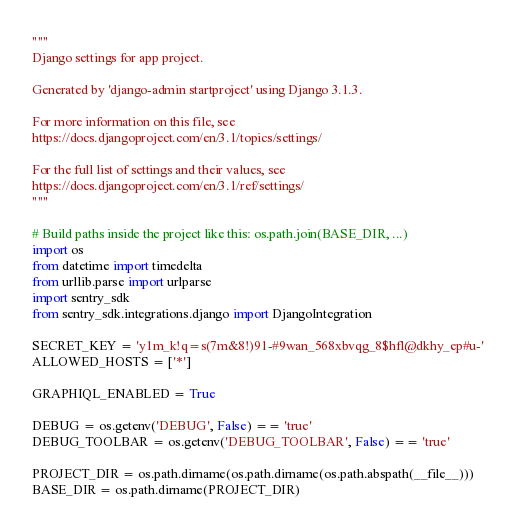Convert code to text. <code><loc_0><loc_0><loc_500><loc_500><_Python_>"""
Django settings for app project.

Generated by 'django-admin startproject' using Django 3.1.3.

For more information on this file, see
https://docs.djangoproject.com/en/3.1/topics/settings/

For the full list of settings and their values, see
https://docs.djangoproject.com/en/3.1/ref/settings/
"""

# Build paths inside the project like this: os.path.join(BASE_DIR, ...)
import os
from datetime import timedelta
from urllib.parse import urlparse
import sentry_sdk
from sentry_sdk.integrations.django import DjangoIntegration

SECRET_KEY = 'y1m_k!q=s(7m&8!)91-#9wan_568xbvqg_8$hfl@dkhy_ep#u-'
ALLOWED_HOSTS = ['*']

GRAPHIQL_ENABLED = True

DEBUG = os.getenv('DEBUG', False) == 'true'
DEBUG_TOOLBAR = os.getenv('DEBUG_TOOLBAR', False) == 'true'

PROJECT_DIR = os.path.dirname(os.path.dirname(os.path.abspath(__file__)))
BASE_DIR = os.path.dirname(PROJECT_DIR)
</code> 